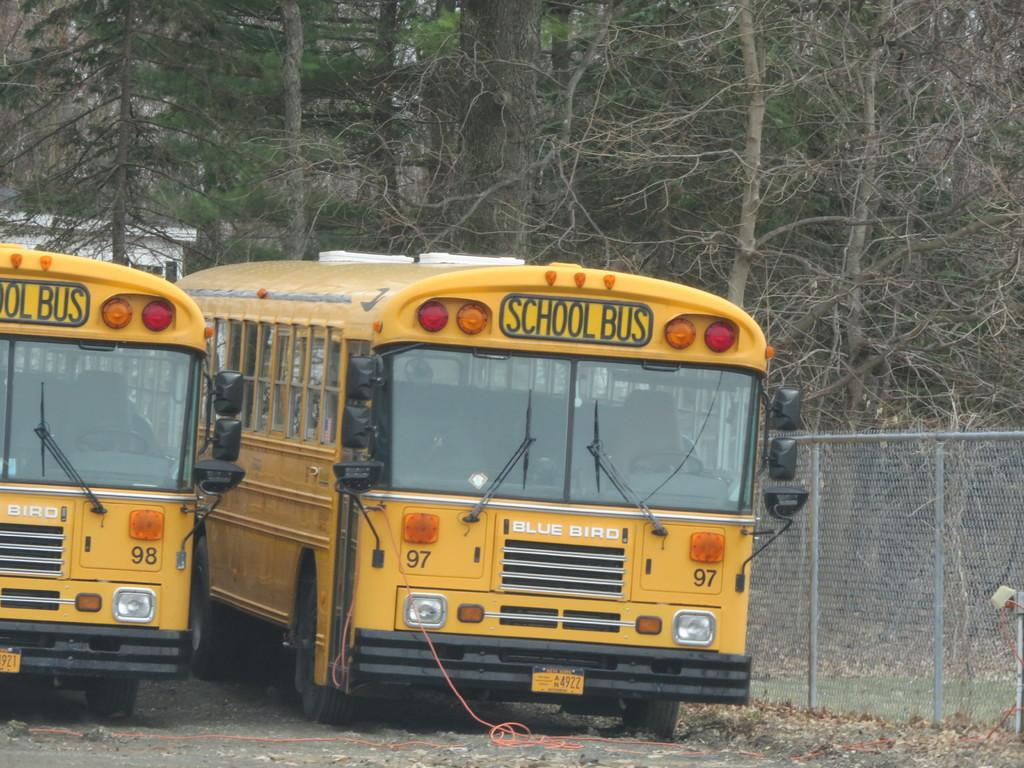What type of vegetation can be seen in the background of the image? There are trees in the background of the image. What color are the school buses in the image? The school buses in the image are yellow. What is located on the right side of the image? There is a fence on the right side of the image. Is there any coal visible in the image? No, there is no coal present in the image. Can you see a hose being used in the image? No, there is no hose visible in the image. 